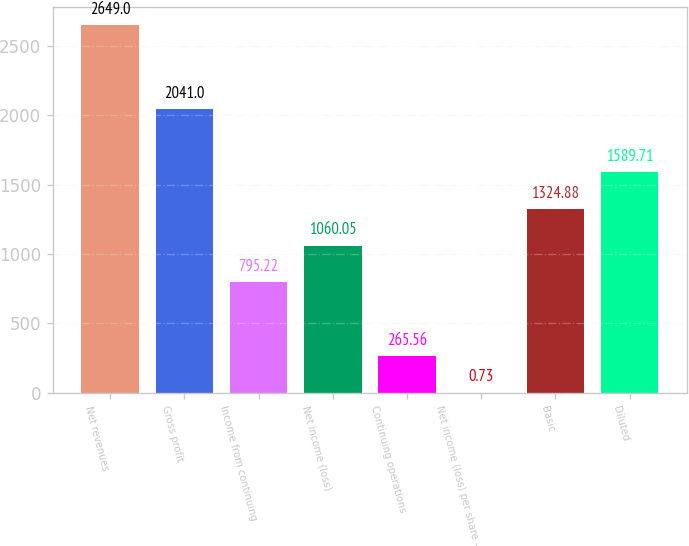<chart> <loc_0><loc_0><loc_500><loc_500><bar_chart><fcel>Net revenues<fcel>Gross profit<fcel>Income from continuing<fcel>Net income (loss)<fcel>Continuing operations<fcel>Net income (loss) per share -<fcel>Basic<fcel>Diluted<nl><fcel>2649<fcel>2041<fcel>795.22<fcel>1060.05<fcel>265.56<fcel>0.73<fcel>1324.88<fcel>1589.71<nl></chart> 